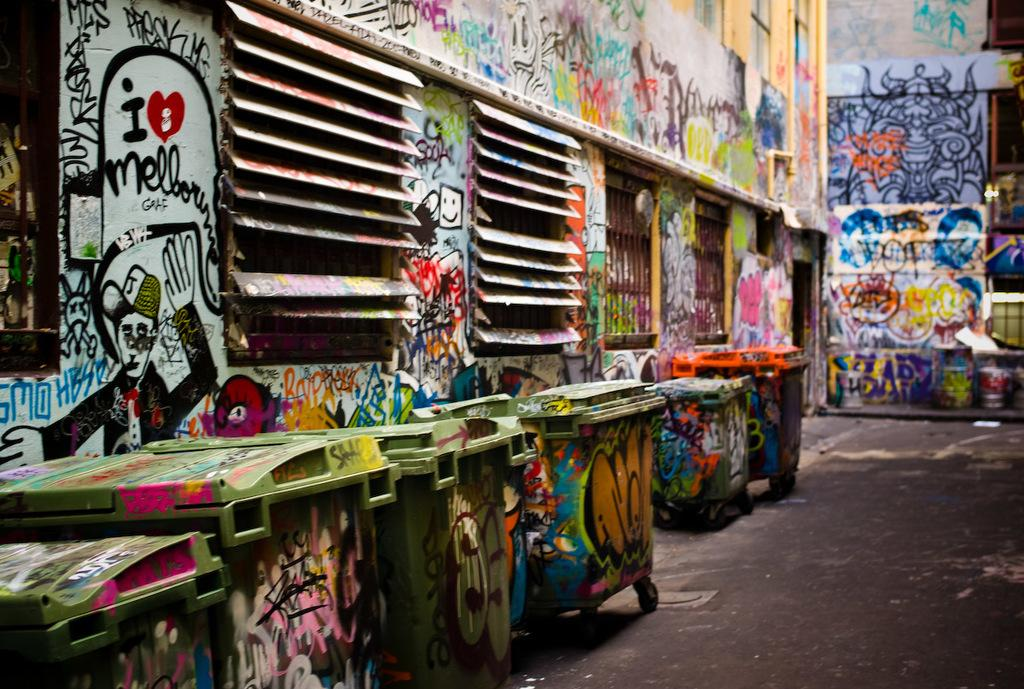Provide a one-sentence caption for the provided image. Trash cans and walls with graffiti on them in an alley. 